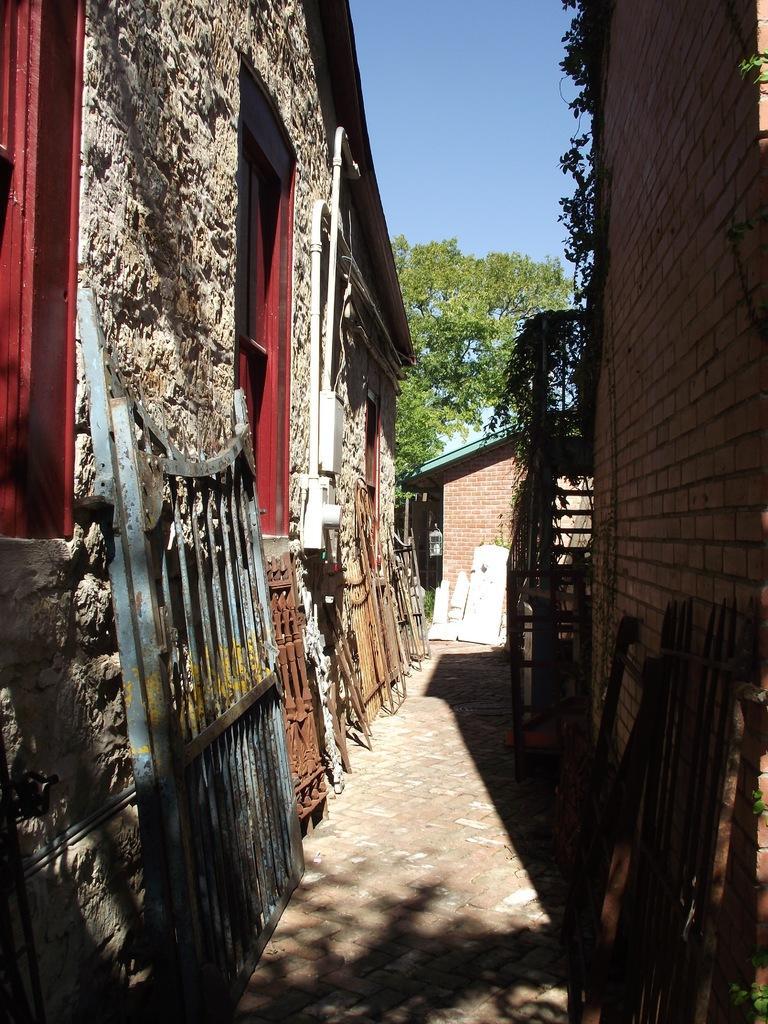Can you describe this image briefly? In the image we can see there is a lane and on either sides there are buildings and there is a stand of iron and there are other rods which are kept standing side and there are trees and clear sky. 